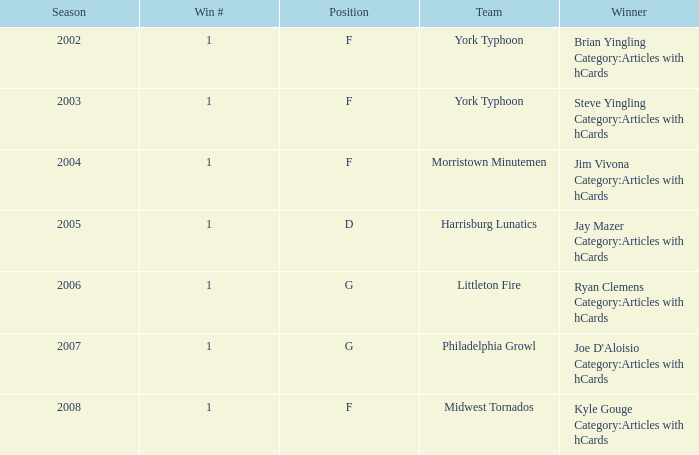Who was the winner in the 2008 season? Kyle Gouge Category:Articles with hCards. 